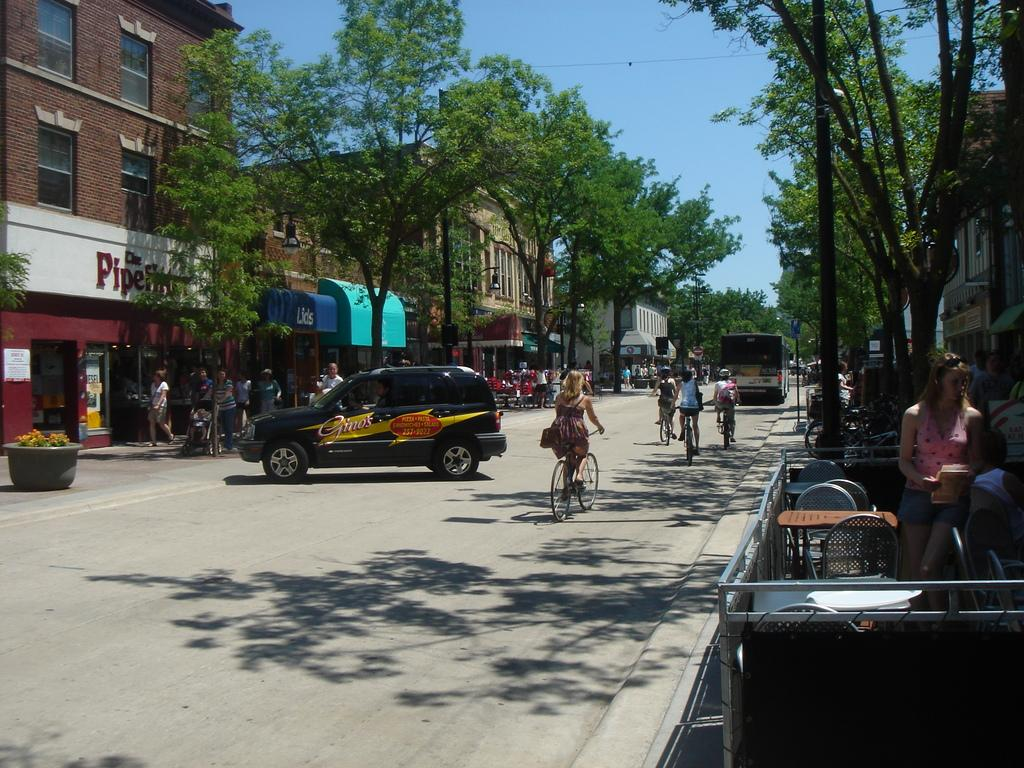<image>
Share a concise interpretation of the image provided. Gino's pizza, pasta, sandwiches, and salad logo on a jeep. 